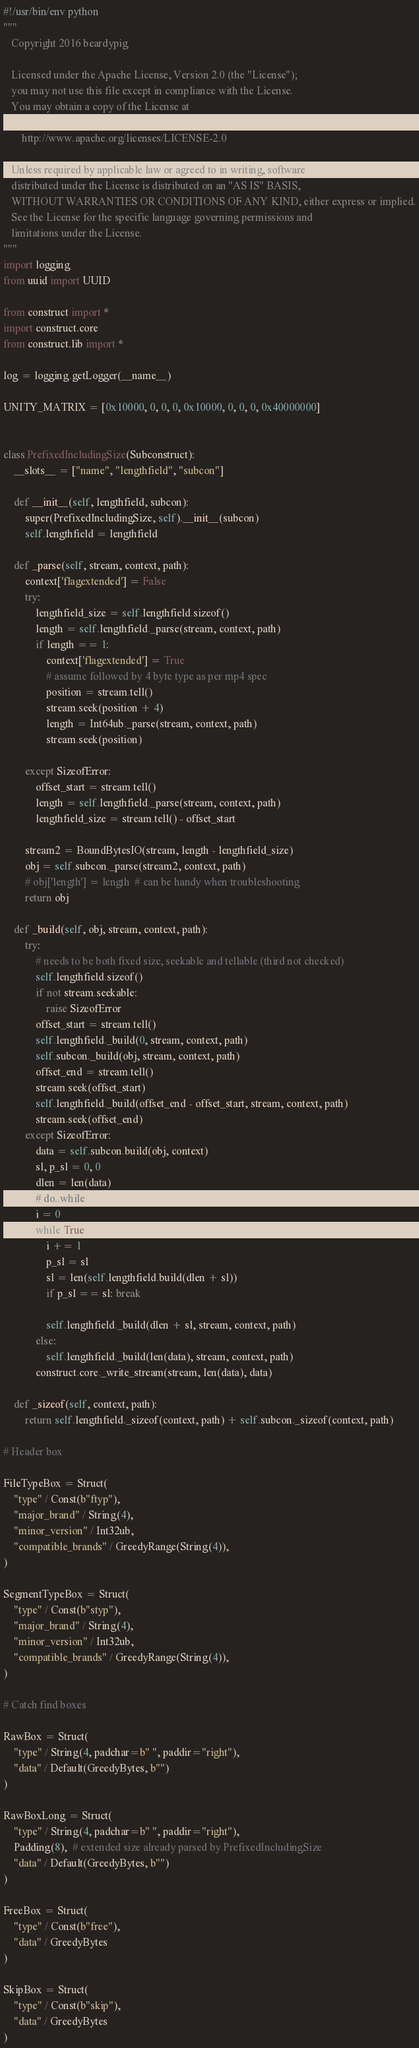<code> <loc_0><loc_0><loc_500><loc_500><_Python_>#!/usr/bin/env python
"""
   Copyright 2016 beardypig

   Licensed under the Apache License, Version 2.0 (the "License");
   you may not use this file except in compliance with the License.
   You may obtain a copy of the License at

       http://www.apache.org/licenses/LICENSE-2.0

   Unless required by applicable law or agreed to in writing, software
   distributed under the License is distributed on an "AS IS" BASIS,
   WITHOUT WARRANTIES OR CONDITIONS OF ANY KIND, either express or implied.
   See the License for the specific language governing permissions and
   limitations under the License.
"""
import logging
from uuid import UUID

from construct import *
import construct.core
from construct.lib import *

log = logging.getLogger(__name__)

UNITY_MATRIX = [0x10000, 0, 0, 0, 0x10000, 0, 0, 0, 0x40000000]


class PrefixedIncludingSize(Subconstruct):
    __slots__ = ["name", "lengthfield", "subcon"]

    def __init__(self, lengthfield, subcon):
        super(PrefixedIncludingSize, self).__init__(subcon)
        self.lengthfield = lengthfield

    def _parse(self, stream, context, path):
        context['flagextended'] = False
        try:
            lengthfield_size = self.lengthfield.sizeof()
            length = self.lengthfield._parse(stream, context, path)
            if length == 1:
                context['flagextended'] = True
                # assume followed by 4 byte type as per mp4 spec
                position = stream.tell()
                stream.seek(position + 4)
                length = Int64ub._parse(stream, context, path)
                stream.seek(position)

        except SizeofError:
            offset_start = stream.tell()
            length = self.lengthfield._parse(stream, context, path)
            lengthfield_size = stream.tell() - offset_start

        stream2 = BoundBytesIO(stream, length - lengthfield_size)
        obj = self.subcon._parse(stream2, context, path)
        # obj['length'] = length  # can be handy when troubleshooting
        return obj

    def _build(self, obj, stream, context, path):
        try:
            # needs to be both fixed size, seekable and tellable (third not checked)
            self.lengthfield.sizeof()
            if not stream.seekable:
                raise SizeofError
            offset_start = stream.tell()
            self.lengthfield._build(0, stream, context, path)
            self.subcon._build(obj, stream, context, path)
            offset_end = stream.tell()
            stream.seek(offset_start)
            self.lengthfield._build(offset_end - offset_start, stream, context, path)
            stream.seek(offset_end)
        except SizeofError:
            data = self.subcon.build(obj, context)
            sl, p_sl = 0, 0
            dlen = len(data)
            # do..while
            i = 0
            while True:
                i += 1
                p_sl = sl
                sl = len(self.lengthfield.build(dlen + sl))
                if p_sl == sl: break

                self.lengthfield._build(dlen + sl, stream, context, path)
            else:
                self.lengthfield._build(len(data), stream, context, path)
            construct.core._write_stream(stream, len(data), data)

    def _sizeof(self, context, path):
        return self.lengthfield._sizeof(context, path) + self.subcon._sizeof(context, path)

# Header box

FileTypeBox = Struct(
    "type" / Const(b"ftyp"),
    "major_brand" / String(4),
    "minor_version" / Int32ub,
    "compatible_brands" / GreedyRange(String(4)),
)

SegmentTypeBox = Struct(
    "type" / Const(b"styp"),
    "major_brand" / String(4),
    "minor_version" / Int32ub,
    "compatible_brands" / GreedyRange(String(4)),
)

# Catch find boxes

RawBox = Struct(
    "type" / String(4, padchar=b" ", paddir="right"),
    "data" / Default(GreedyBytes, b"")
)

RawBoxLong = Struct(
    "type" / String(4, padchar=b" ", paddir="right"),
    Padding(8),  # extended size already parsed by PrefixedIncludingSize
    "data" / Default(GreedyBytes, b"")
)

FreeBox = Struct(
    "type" / Const(b"free"),
    "data" / GreedyBytes
)

SkipBox = Struct(
    "type" / Const(b"skip"),
    "data" / GreedyBytes
)
</code> 